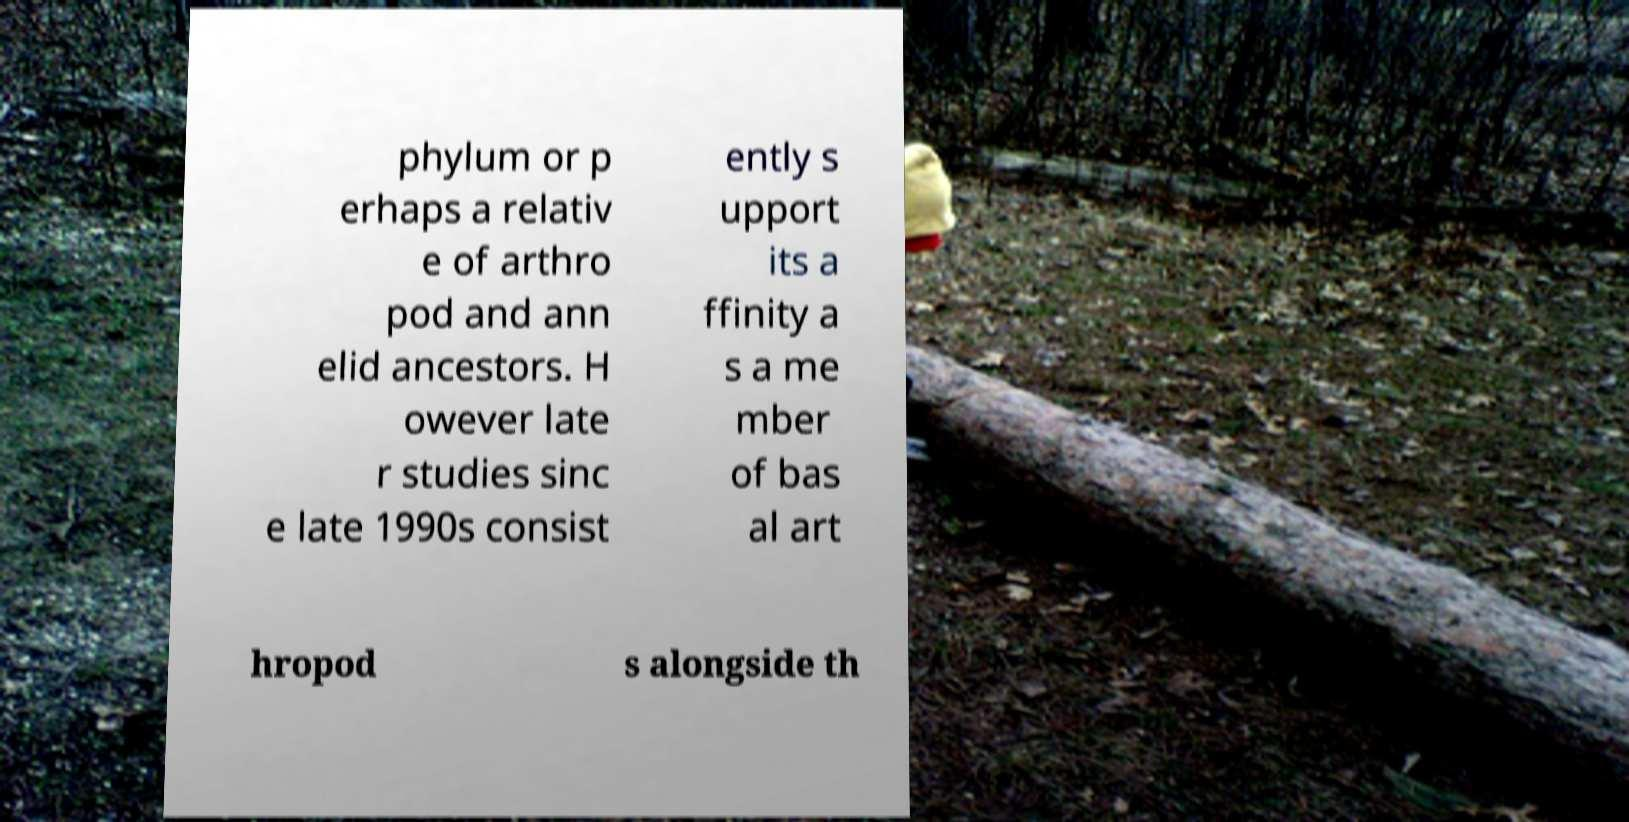Could you extract and type out the text from this image? phylum or p erhaps a relativ e of arthro pod and ann elid ancestors. H owever late r studies sinc e late 1990s consist ently s upport its a ffinity a s a me mber of bas al art hropod s alongside th 